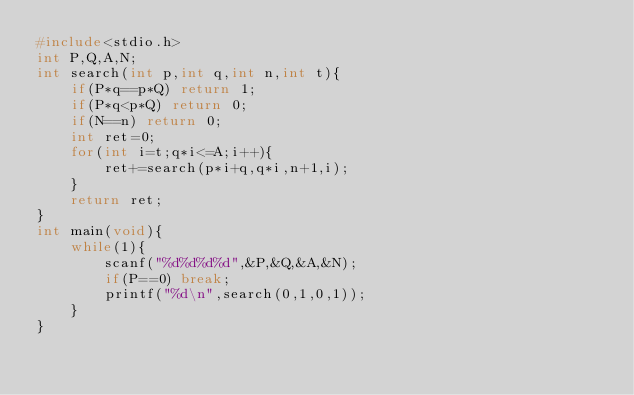<code> <loc_0><loc_0><loc_500><loc_500><_C_>#include<stdio.h>
int P,Q,A,N;
int search(int p,int q,int n,int t){
    if(P*q==p*Q) return 1;
    if(P*q<p*Q) return 0;
    if(N==n) return 0;
    int ret=0;
    for(int i=t;q*i<=A;i++){
        ret+=search(p*i+q,q*i,n+1,i);
    }
    return ret;
}
int main(void){
    while(1){
        scanf("%d%d%d%d",&P,&Q,&A,&N);
        if(P==0) break;
        printf("%d\n",search(0,1,0,1));
    }
}

</code> 